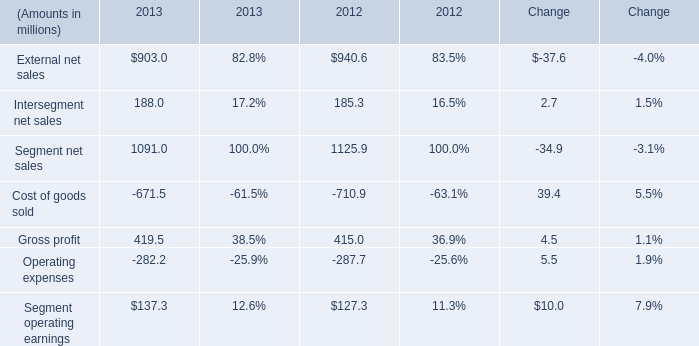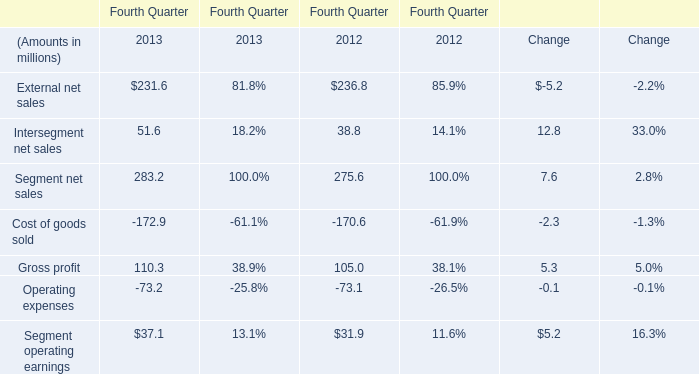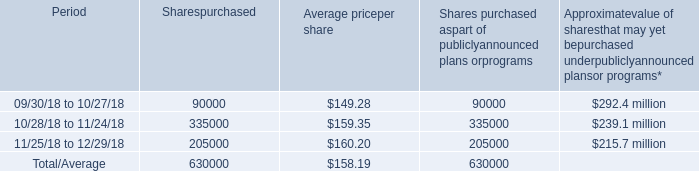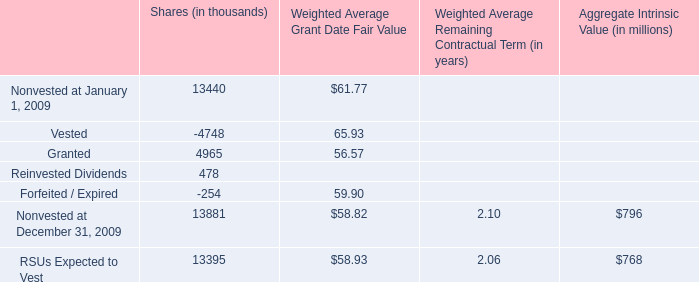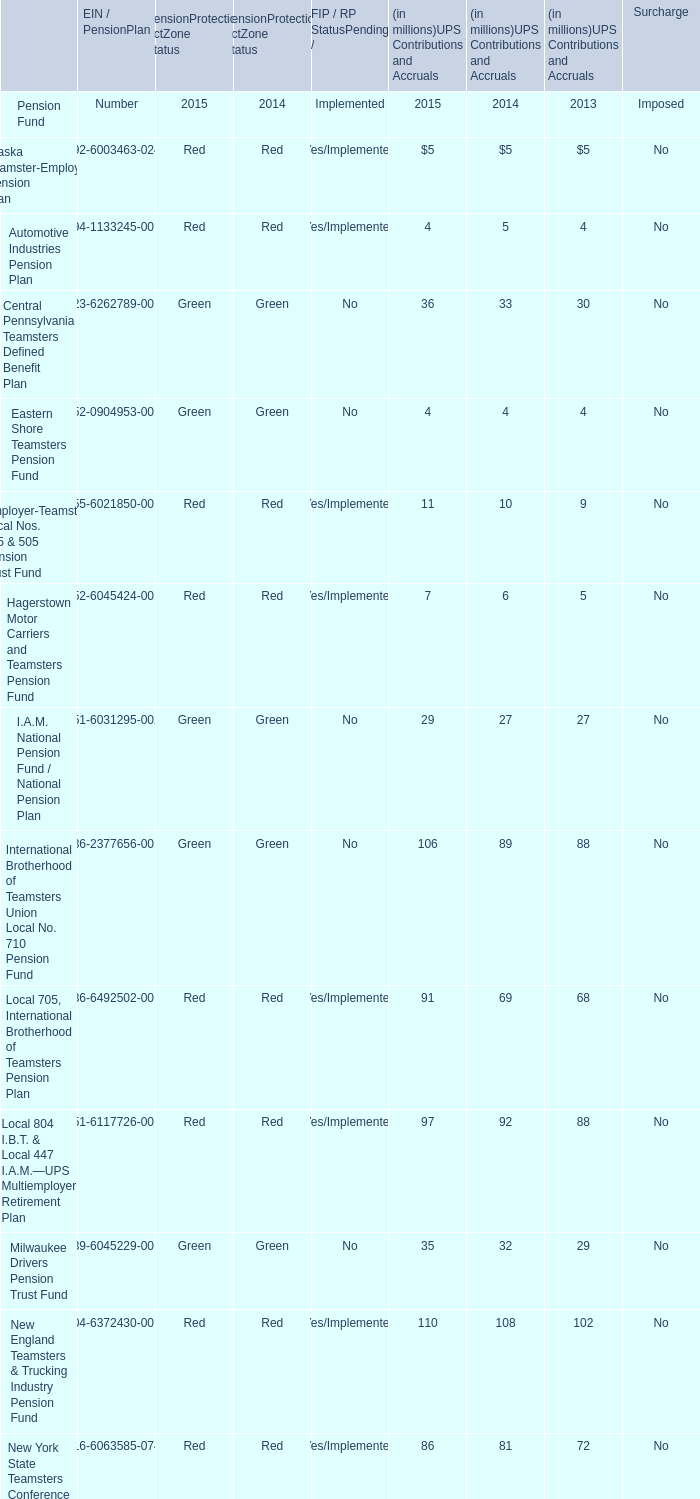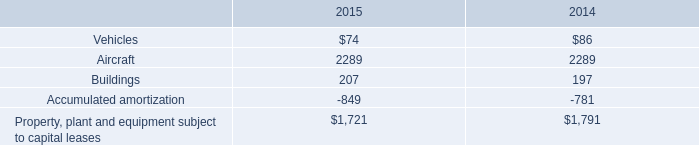What is the sum of Segment operating earnings in the range of 30 and 200 in 2012? (in million) 
Computations: (38.8 + 105)
Answer: 143.8. 